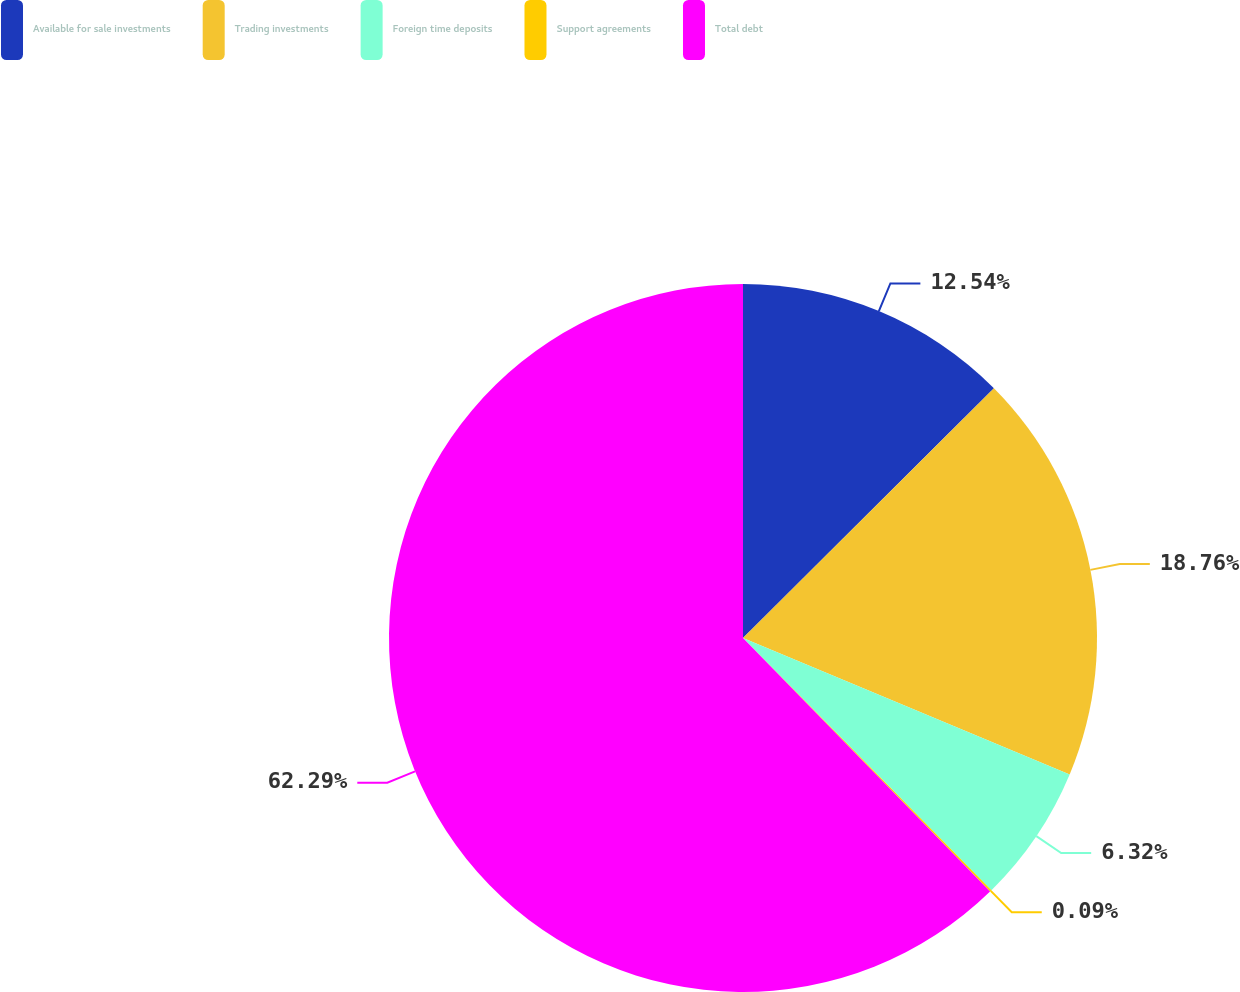Convert chart to OTSL. <chart><loc_0><loc_0><loc_500><loc_500><pie_chart><fcel>Available for sale investments<fcel>Trading investments<fcel>Foreign time deposits<fcel>Support agreements<fcel>Total debt<nl><fcel>12.54%<fcel>18.76%<fcel>6.32%<fcel>0.09%<fcel>62.3%<nl></chart> 